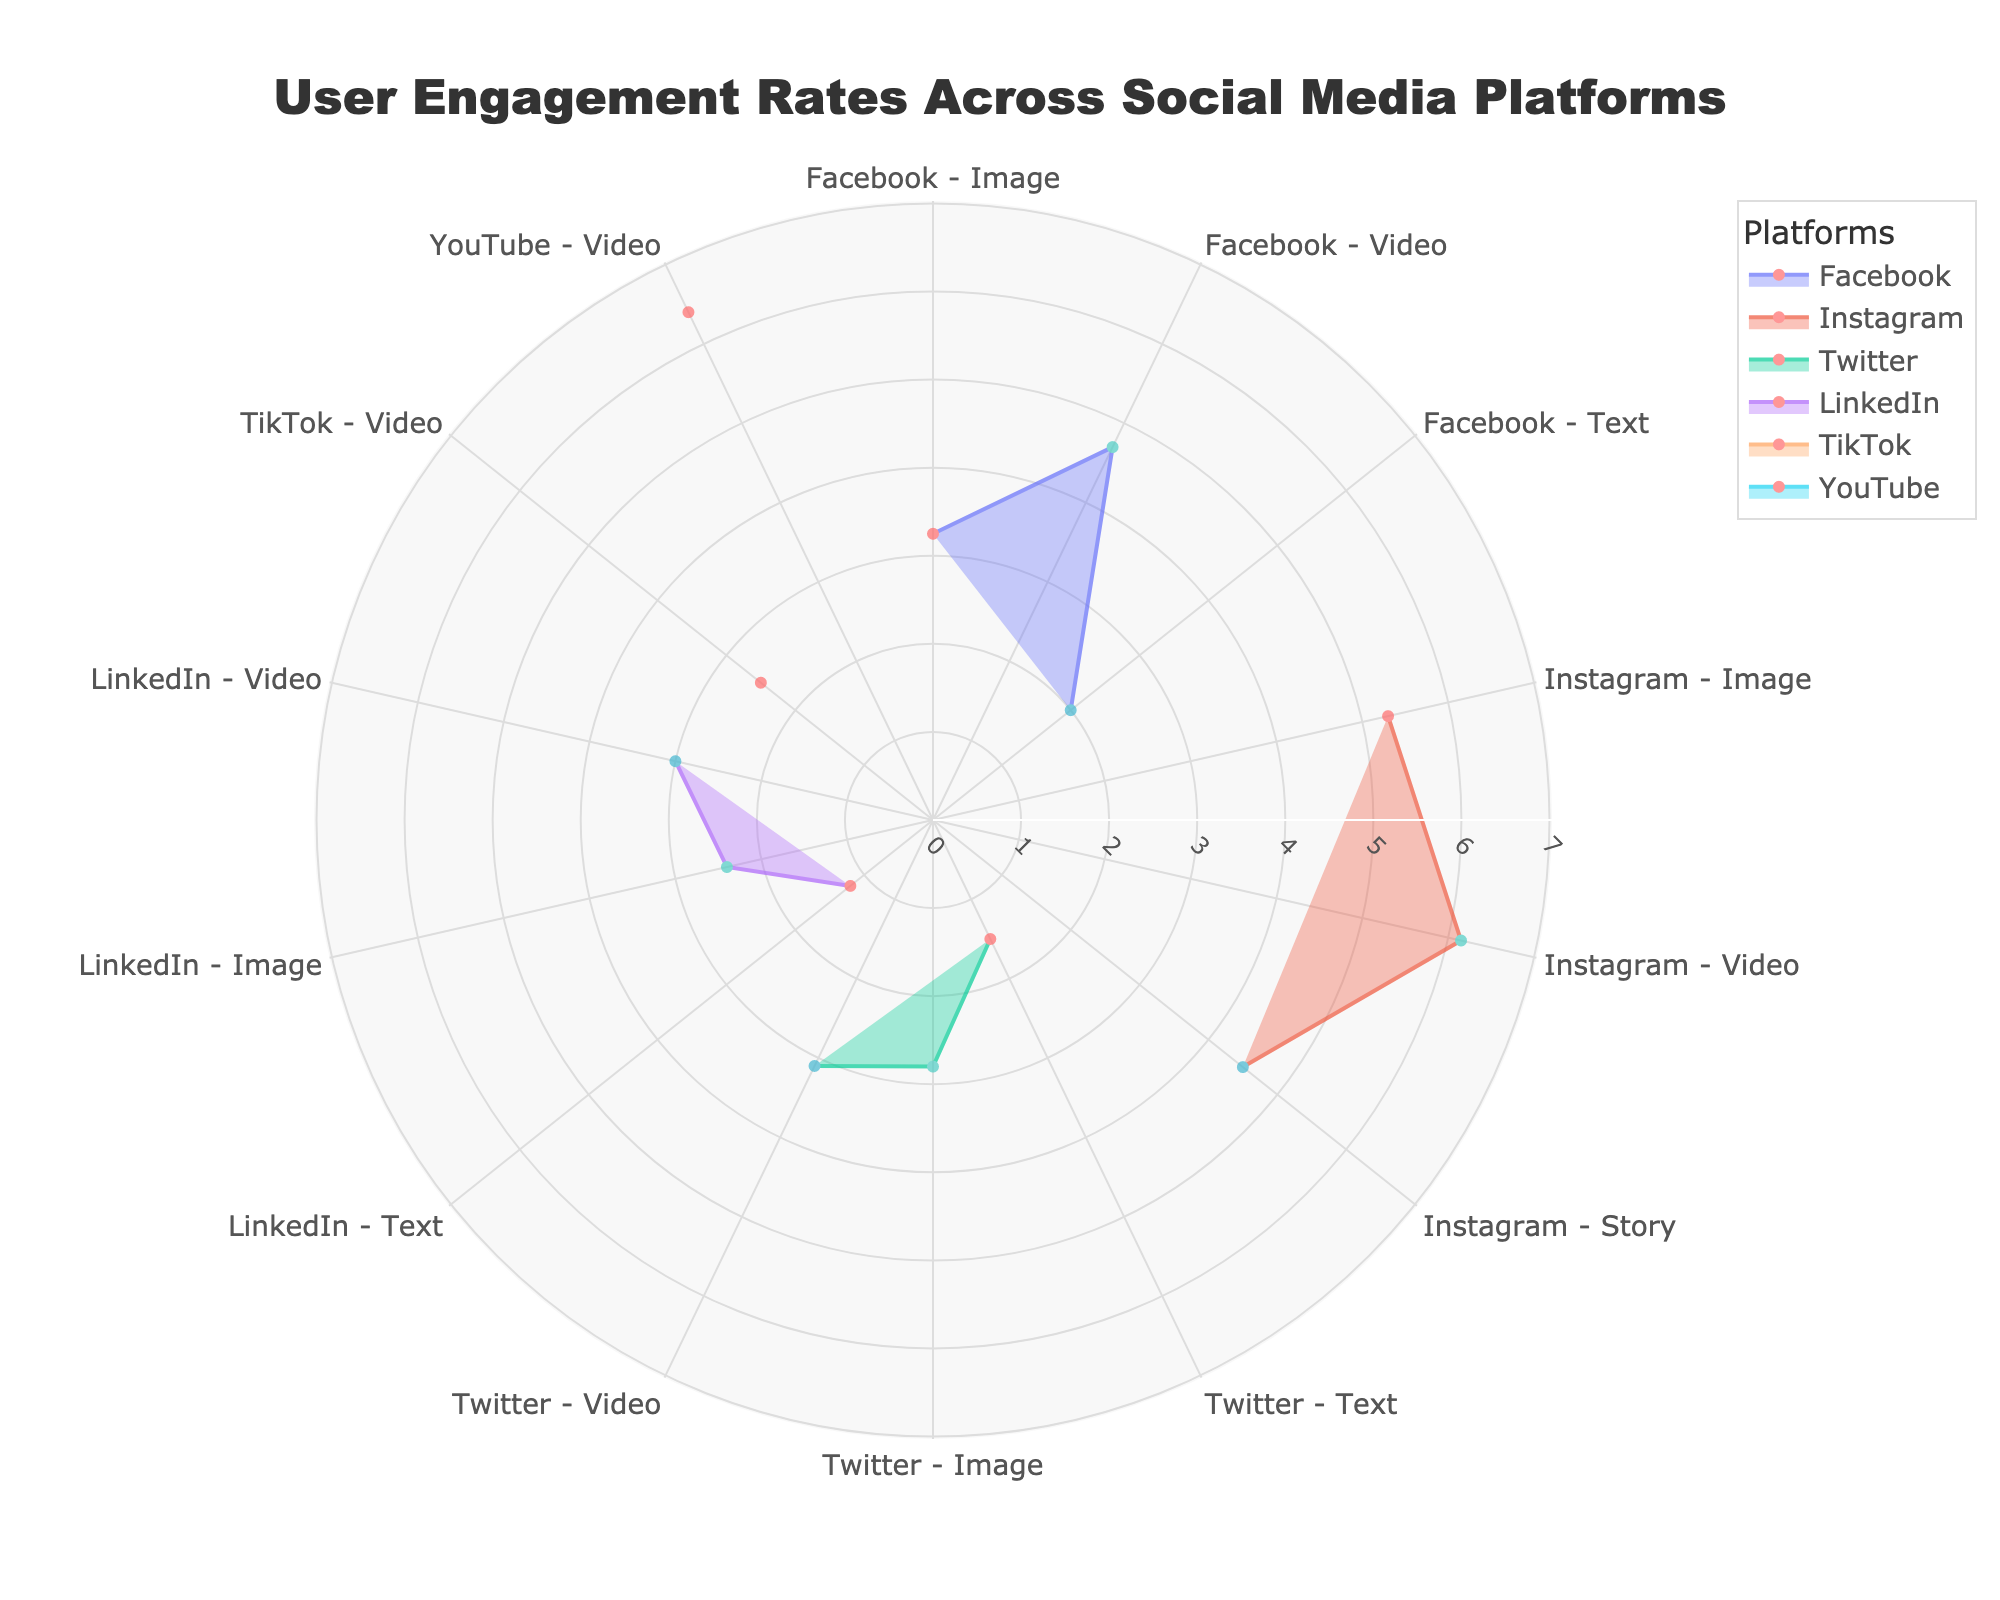What's the highest engagement rate across all platforms and content types? To find the highest engagement rate, look at the data points and identify the one with the maximum value. The YouTube Video has an engagement rate of 6.40, which is the highest in the chart.
Answer: 6.40 Which platform has the lowest engagement rate for text content? Check the engagement rates for text content on all platforms. LinkedIn has the lowest engagement rate for text content with a value of 1.20.
Answer: LinkedIn Compare the engagement rate of Instagram Story and Facebook Video. Which one is higher? Look at the engagement rates for Instagram Story and Facebook Video. Instagram Story has an engagement rate of 4.50, while Facebook Video has an engagement rate of 4.70. So, Facebook Video has a slightly higher engagement rate.
Answer: Facebook Video Is Twitter's engagement rate for image content higher than for video content? Check the engagement rates of Twitter for image and video content. Twitter's image content has an engagement rate of 2.80 and video content has an engagement rate of 3.10. Therefore, the engagement rate for video content is higher.
Answer: No What is the average engagement rate across all content types for Facebook? Add the engagement rates of all content types for Facebook and divide by the number of content types. The engagement rates are 3.25 (Image), 4.70 (Video), and 2.00 (Text). Adding them gives 3.25 + 4.70 + 2.00 = 9.95. Dividing by 3 gives an average engagement rate of approximately 3.32.
Answer: 3.32 How do the engagement rates of YouTube Video and Instagram Video compare to the other platforms' video content? Compare the engagement rates of YouTube Video (6.40) and Instagram Video (6.15) to other video content engagement rates (Facebook 4.70, Twitter 3.10, LinkedIn 3.00, and TikTok 2.50). Both YouTube and Instagram have significantly higher engagement rates than other platforms' video content.
Answer: Higher Which platform has the most comparable engagement rates across different content types? Examine the engagement rates for each platform across their content types. LinkedIn has relatively similar engagement rates of 1.20 (Text), 2.40 (Image), and 3.00 (Video), indicating more comparable rates.
Answer: LinkedIn Which platform and content type combination has the second highest engagement rate? Identify the engagement rates in descending order. YouTube Video has the highest at 6.40, and Instagram Video follows as the second highest with 6.15.
Answer: Instagram Video Looking at all the platforms, which type of content generally receives the highest engagement rate? Analyze the engagement rates of each content type. Video content generally has the highest engagement rates, with the highest values seen in YouTube Video (6.40) and Instagram Video (6.15).
Answer: Video 